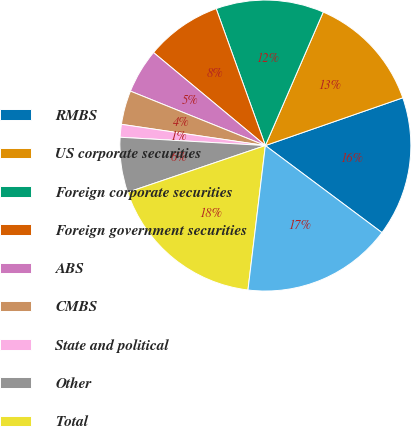Convert chart. <chart><loc_0><loc_0><loc_500><loc_500><pie_chart><fcel>RMBS<fcel>US corporate securities<fcel>Foreign corporate securities<fcel>Foreign government securities<fcel>ABS<fcel>CMBS<fcel>State and political<fcel>Other<fcel>Total<fcel>Mortgage-backed<nl><fcel>15.53%<fcel>13.17%<fcel>12.0%<fcel>8.47%<fcel>4.94%<fcel>3.77%<fcel>1.42%<fcel>6.12%<fcel>17.88%<fcel>16.7%<nl></chart> 